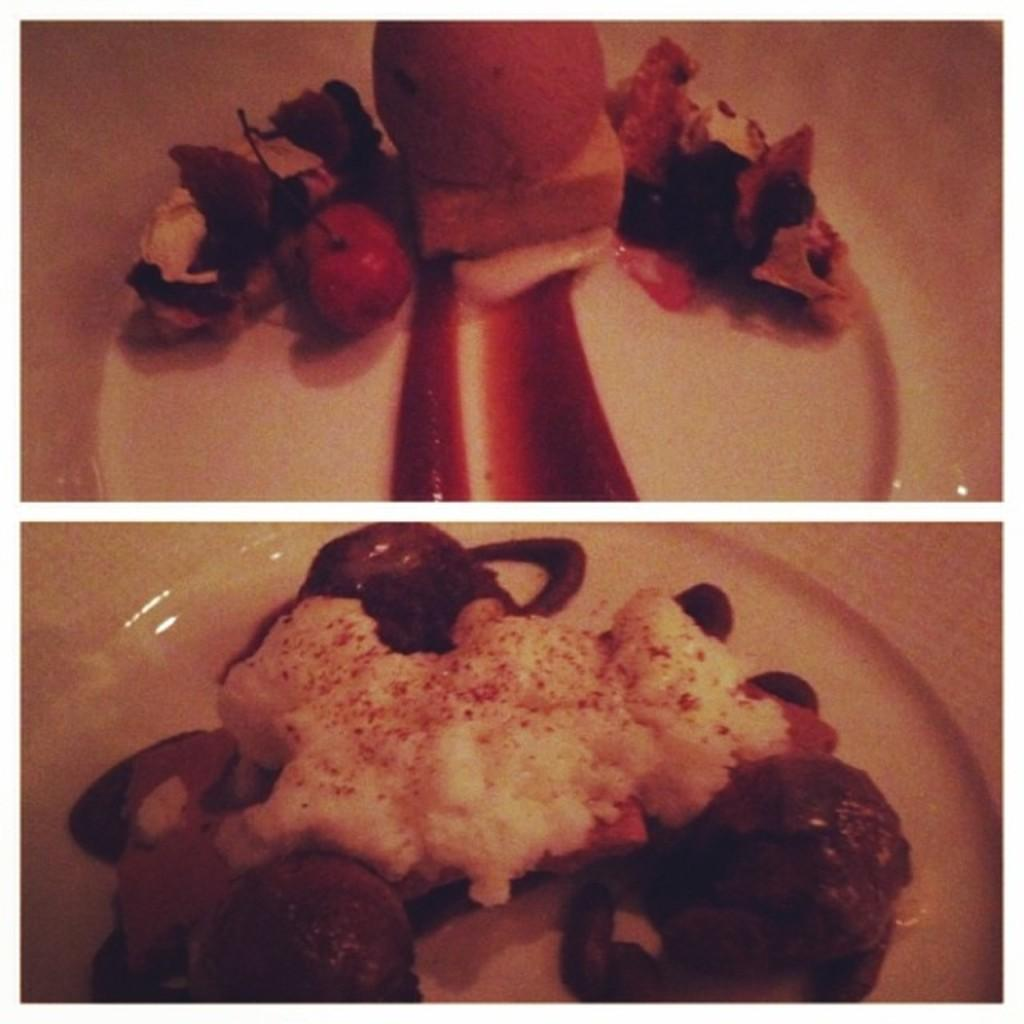What is the main subject of the image? The main subject of the image is a collage of photos. Can you describe any specific elements within the collage? Yes, there is a plate in the collage. What is on the plate? There is a food item on the plate. What type of teaching is happening in the image? There is no teaching activity present in the image; it features a collage of photos with a plate and a food item. 